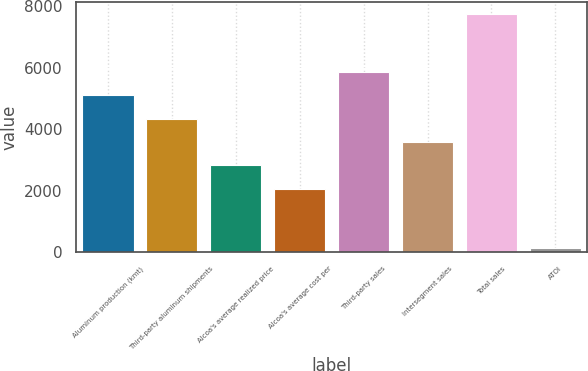Convert chart to OTSL. <chart><loc_0><loc_0><loc_500><loc_500><bar_chart><fcel>Aluminum production (kmt)<fcel>Third-party aluminum shipments<fcel>Alcoa's average realized price<fcel>Alcoa's average cost per<fcel>Third-party sales<fcel>Intersegment sales<fcel>Total sales<fcel>ATOI<nl><fcel>5106.4<fcel>4345.8<fcel>2824.6<fcel>2064<fcel>5867<fcel>3585.2<fcel>7761<fcel>155<nl></chart> 